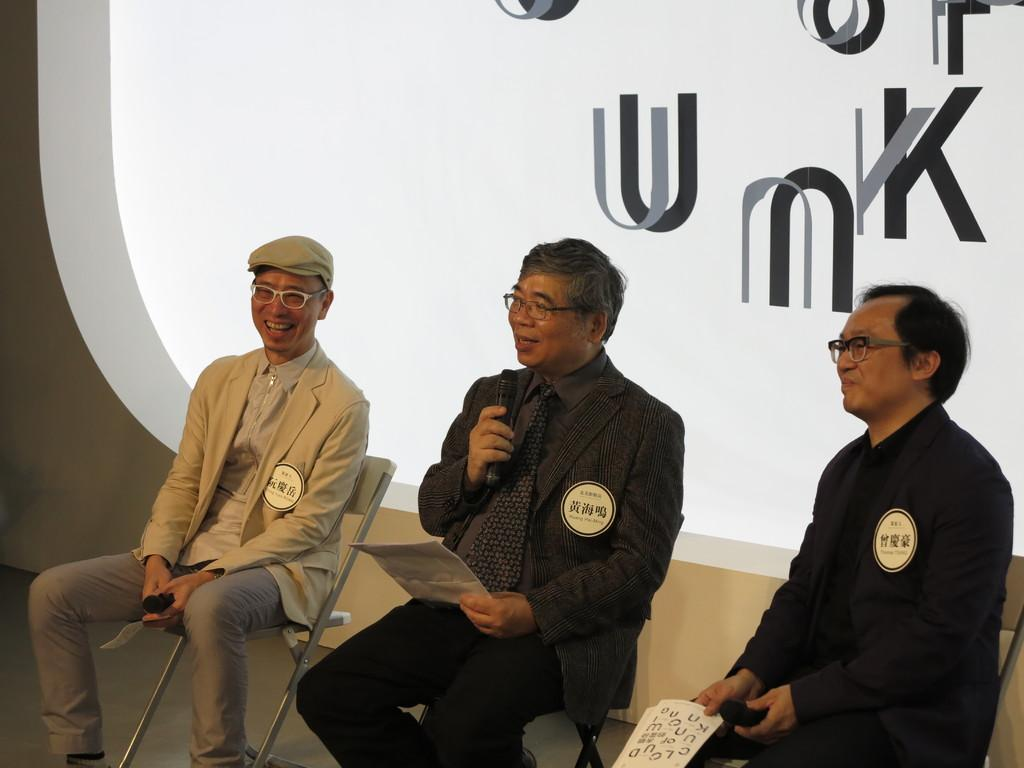How many people are in the image? There are three persons in the image. What are the persons doing in the image? The persons are sitting on chairs and holding mics. What else are the persons holding in the image? The persons are also holding papers. What can be seen in the background of the image? There is a banner in the background of the image. What is written on the banner? Something is written on the banner, but we cannot determine the exact message from the image. What type of rock is being used as a table in the image? There is no rock being used as a table in the image; the persons are sitting on chairs. What color is the jelly on the person's dress in the image? There is no jelly or dress present in the image. 